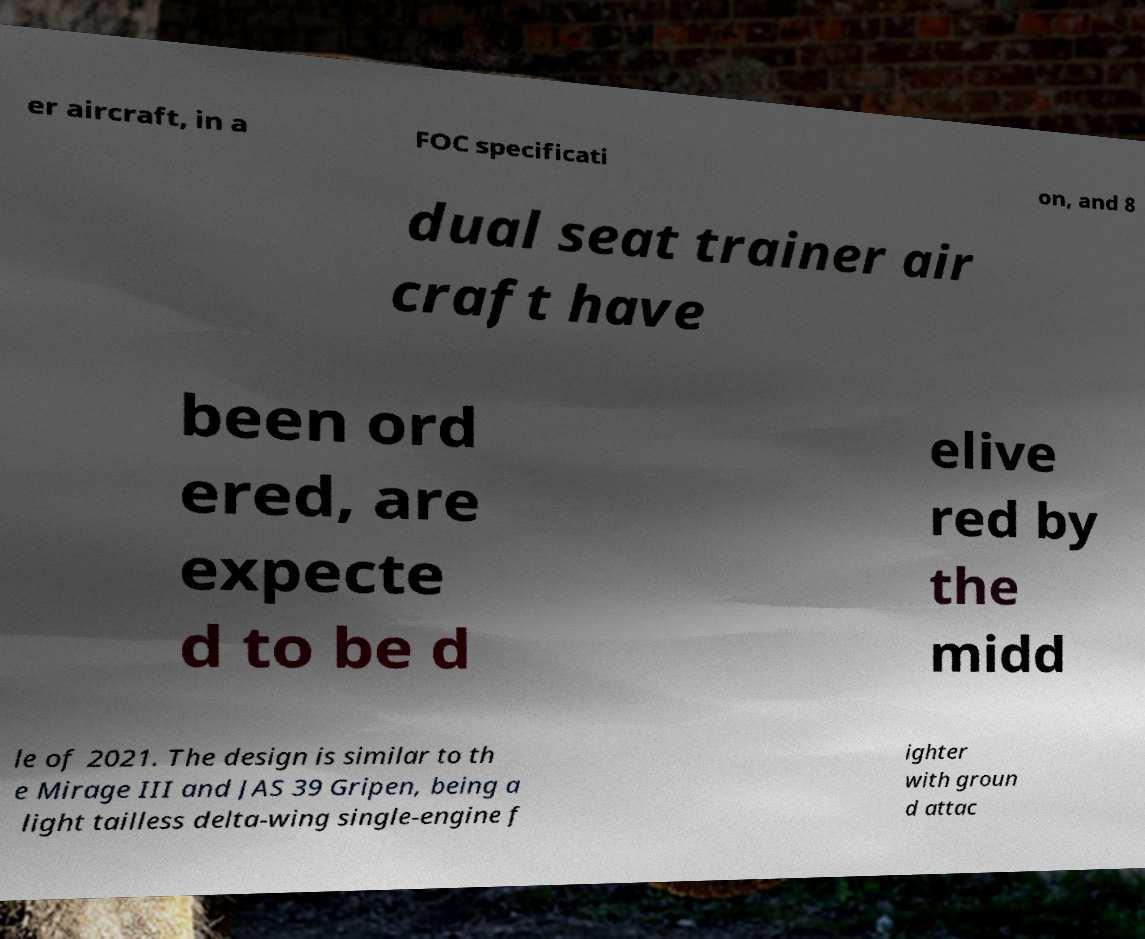What messages or text are displayed in this image? I need them in a readable, typed format. er aircraft, in a FOC specificati on, and 8 dual seat trainer air craft have been ord ered, are expecte d to be d elive red by the midd le of 2021. The design is similar to th e Mirage III and JAS 39 Gripen, being a light tailless delta-wing single-engine f ighter with groun d attac 